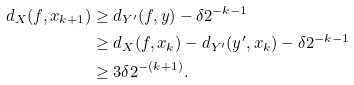Convert formula to latex. <formula><loc_0><loc_0><loc_500><loc_500>d _ { X } ( f , x _ { k + 1 } ) & \geq d _ { Y ^ { \prime } } ( f , y ) - \delta 2 ^ { - k - 1 } \\ & \geq d _ { X } ( f , x _ { k } ) - d _ { Y ^ { \prime } } ( y ^ { \prime } , x _ { k } ) - \delta 2 ^ { - k - 1 } \\ & \geq 3 \delta 2 ^ { - ( k + 1 ) } .</formula> 